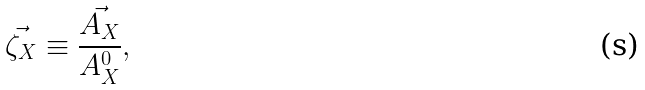<formula> <loc_0><loc_0><loc_500><loc_500>\vec { \zeta _ { X } } \equiv \frac { \vec { A _ { X } } } { A ^ { 0 } _ { X } } ,</formula> 